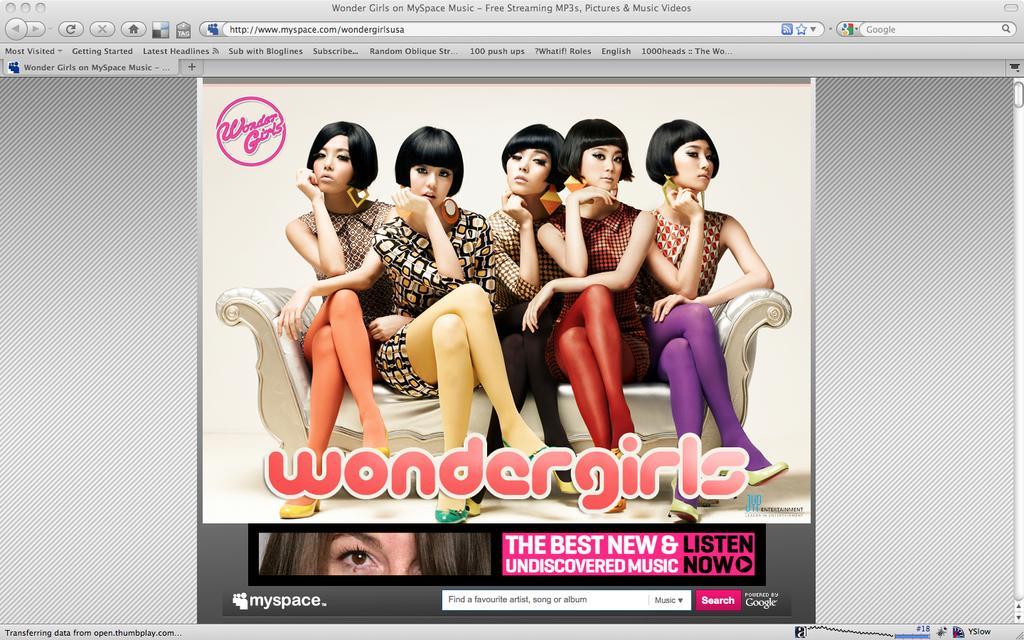How would you summarize this image in a sentence or two? In this image we can see a web page with the image of few people sitting on the couch and some text. 